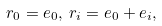<formula> <loc_0><loc_0><loc_500><loc_500>r _ { 0 } = e _ { 0 } , \, r _ { i } = e _ { 0 } + e _ { i } ,</formula> 